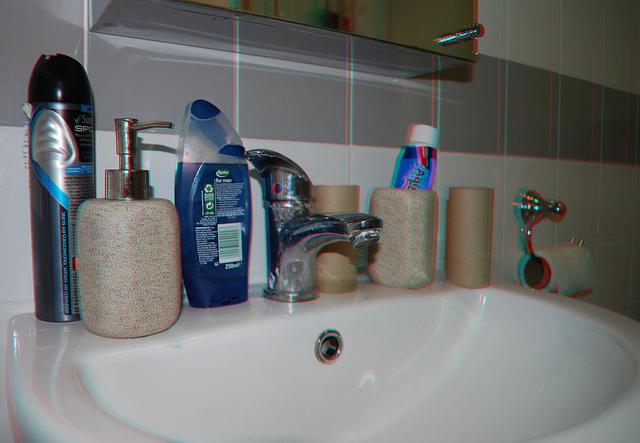Is the shaving cream new?
Quick response, please. No. Is the handle for hot or cold water?
Give a very brief answer. Hot. What room is this?
Short answer required. Bathroom. Is there a full roll of toilet paper?
Write a very short answer. No. 